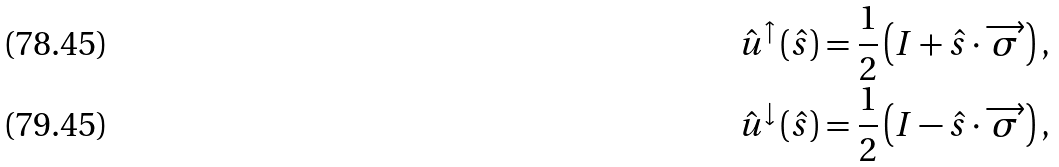Convert formula to latex. <formula><loc_0><loc_0><loc_500><loc_500>\hat { u } ^ { \uparrow } \left ( \hat { s } \right ) & = \frac { 1 } { 2 } \left ( I + \hat { s } \cdot \overrightarrow { \sigma } \right ) , \\ \hat { u } ^ { \downarrow } \left ( \hat { s } \right ) & = \frac { 1 } { 2 } \left ( I - \hat { s } \cdot \overrightarrow { \sigma } \right ) ,</formula> 